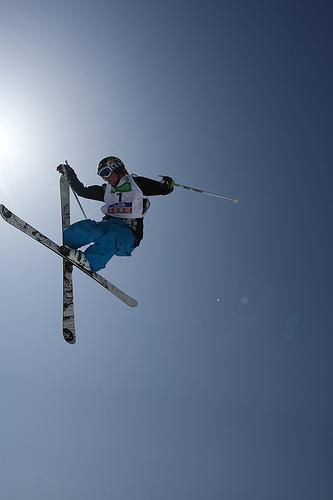How many people are there?
Give a very brief answer. 1. How many boats are in the water?
Give a very brief answer. 0. 